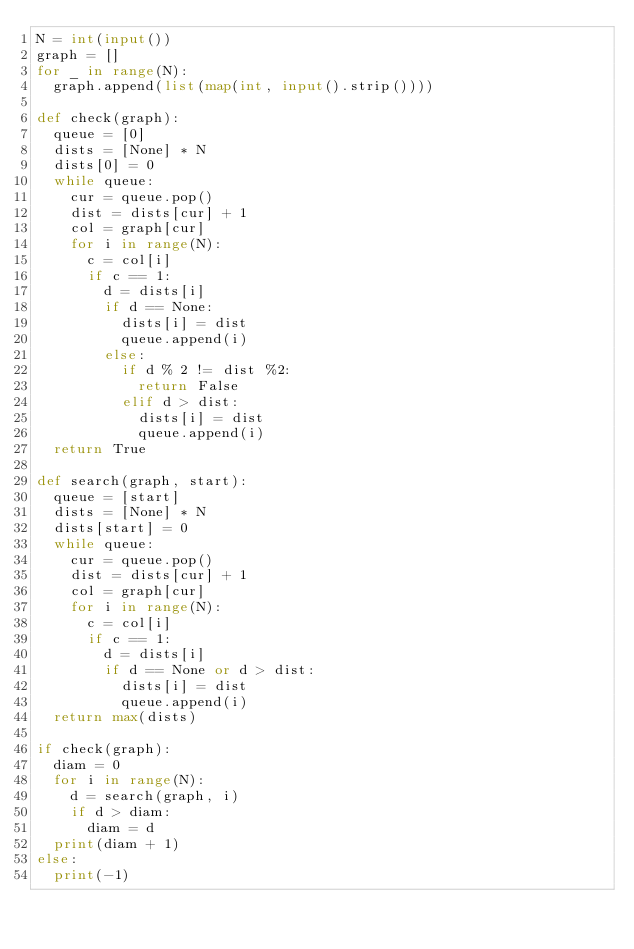<code> <loc_0><loc_0><loc_500><loc_500><_Python_>N = int(input())
graph = []
for _ in range(N):
	graph.append(list(map(int, input().strip())))

def check(graph):
	queue = [0]
	dists = [None] * N
	dists[0] = 0
	while queue:
		cur = queue.pop()
		dist = dists[cur] + 1
		col = graph[cur]
		for i in range(N):
			c = col[i]
			if c == 1:
				d = dists[i]
				if d == None:
					dists[i] = dist
					queue.append(i)
				else:
					if d % 2 != dist %2:
						return False
					elif d > dist:
						dists[i] = dist
						queue.append(i)
	return True

def search(graph, start):
	queue = [start]
	dists = [None] * N
	dists[start] = 0
	while queue:
		cur = queue.pop()
		dist = dists[cur] + 1
		col = graph[cur]
		for i in range(N):
			c = col[i]
			if c == 1:
				d = dists[i]
				if d == None or d > dist:
					dists[i] = dist
					queue.append(i)
	return max(dists)

if check(graph):
	diam = 0
	for i in range(N):
		d = search(graph, i)
		if d > diam:
			diam = d
	print(diam + 1)
else:
	print(-1)
</code> 